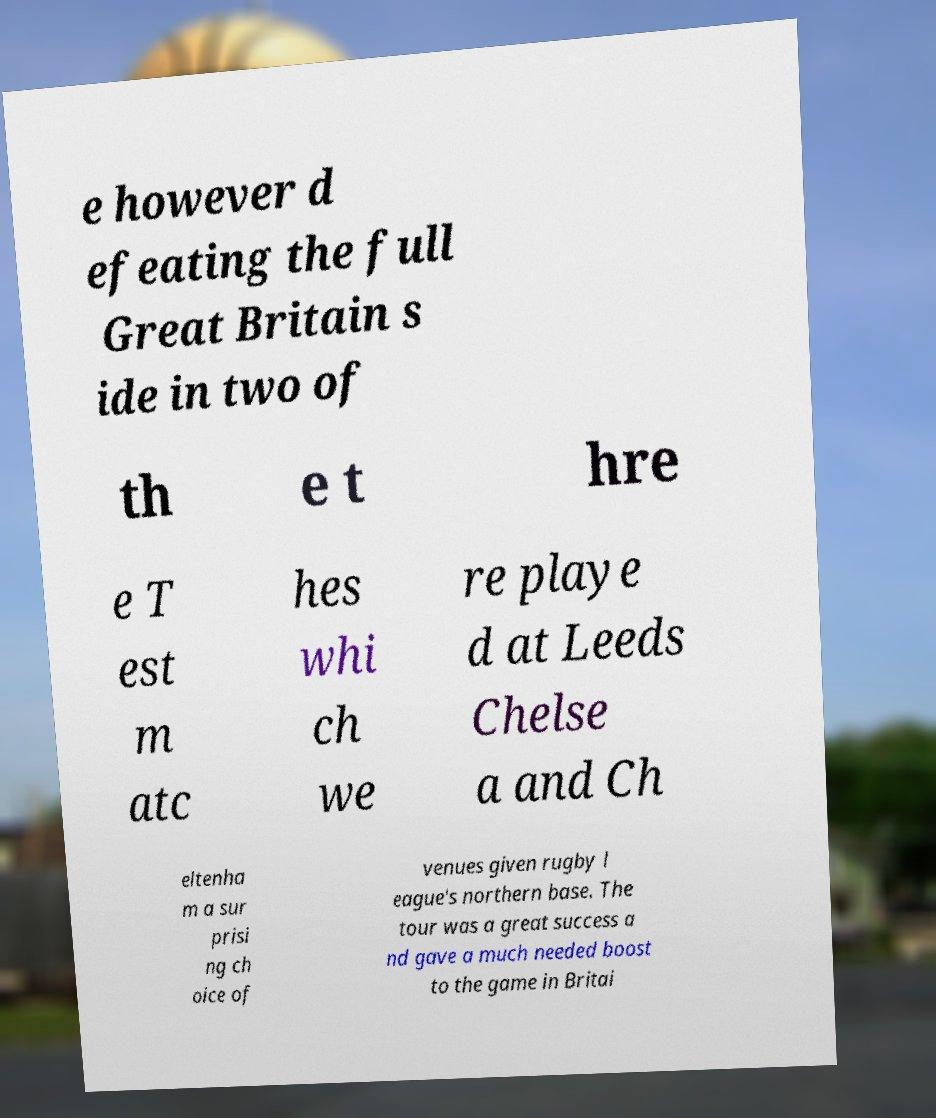Could you assist in decoding the text presented in this image and type it out clearly? e however d efeating the full Great Britain s ide in two of th e t hre e T est m atc hes whi ch we re playe d at Leeds Chelse a and Ch eltenha m a sur prisi ng ch oice of venues given rugby l eague's northern base. The tour was a great success a nd gave a much needed boost to the game in Britai 